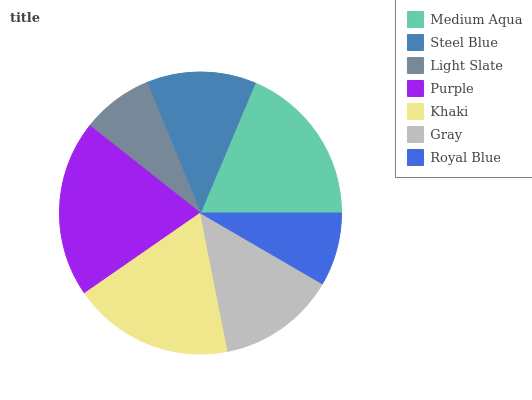Is Light Slate the minimum?
Answer yes or no. Yes. Is Purple the maximum?
Answer yes or no. Yes. Is Steel Blue the minimum?
Answer yes or no. No. Is Steel Blue the maximum?
Answer yes or no. No. Is Medium Aqua greater than Steel Blue?
Answer yes or no. Yes. Is Steel Blue less than Medium Aqua?
Answer yes or no. Yes. Is Steel Blue greater than Medium Aqua?
Answer yes or no. No. Is Medium Aqua less than Steel Blue?
Answer yes or no. No. Is Gray the high median?
Answer yes or no. Yes. Is Gray the low median?
Answer yes or no. Yes. Is Light Slate the high median?
Answer yes or no. No. Is Steel Blue the low median?
Answer yes or no. No. 